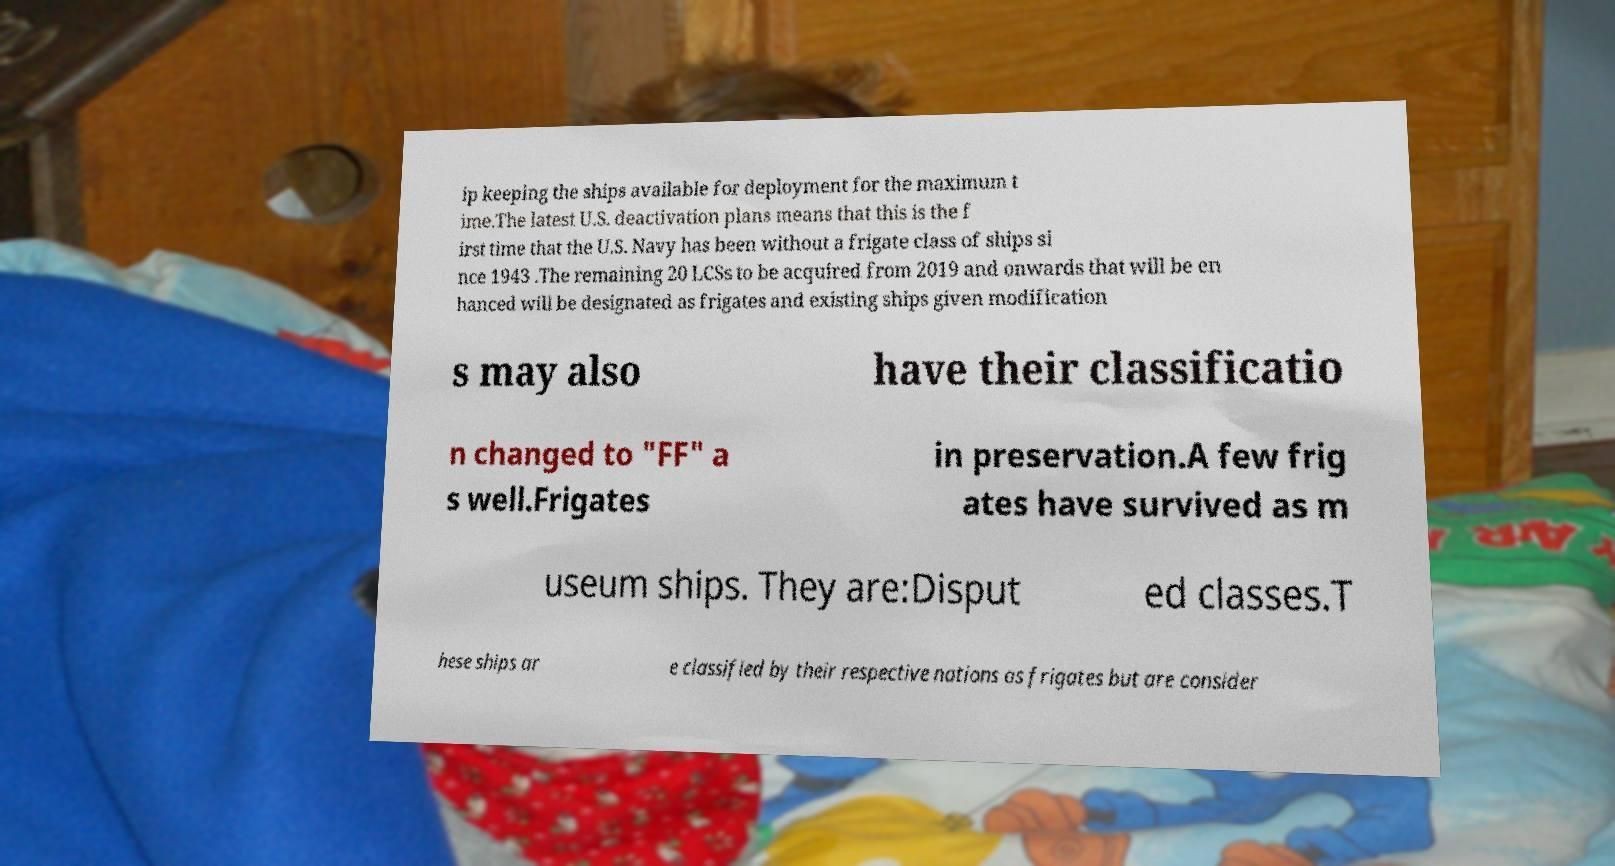Can you read and provide the text displayed in the image?This photo seems to have some interesting text. Can you extract and type it out for me? ip keeping the ships available for deployment for the maximum t ime.The latest U.S. deactivation plans means that this is the f irst time that the U.S. Navy has been without a frigate class of ships si nce 1943 .The remaining 20 LCSs to be acquired from 2019 and onwards that will be en hanced will be designated as frigates and existing ships given modification s may also have their classificatio n changed to "FF" a s well.Frigates in preservation.A few frig ates have survived as m useum ships. They are:Disput ed classes.T hese ships ar e classified by their respective nations as frigates but are consider 